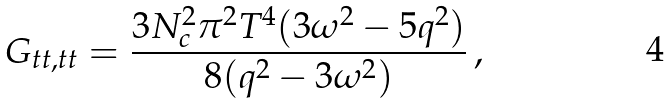<formula> <loc_0><loc_0><loc_500><loc_500>G _ { t t , t t } = \frac { 3 N _ { c } ^ { 2 } \pi ^ { 2 } T ^ { 4 } ( 3 \omega ^ { 2 } - 5 q ^ { 2 } ) } { 8 ( q ^ { 2 } - 3 \omega ^ { 2 } ) } \, ,</formula> 